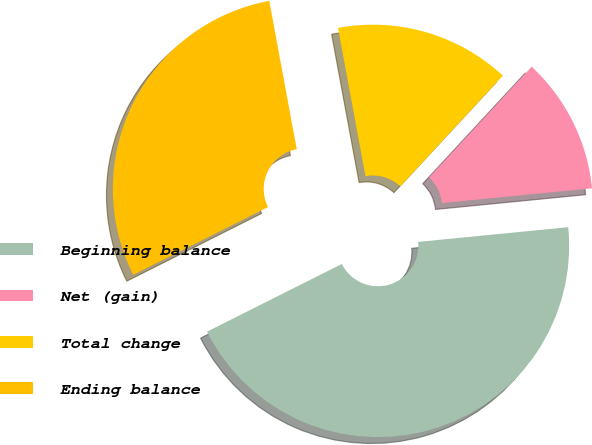Convert chart to OTSL. <chart><loc_0><loc_0><loc_500><loc_500><pie_chart><fcel>Beginning balance<fcel>Net (gain)<fcel>Total change<fcel>Ending balance<nl><fcel>44.15%<fcel>11.55%<fcel>14.81%<fcel>29.49%<nl></chart> 